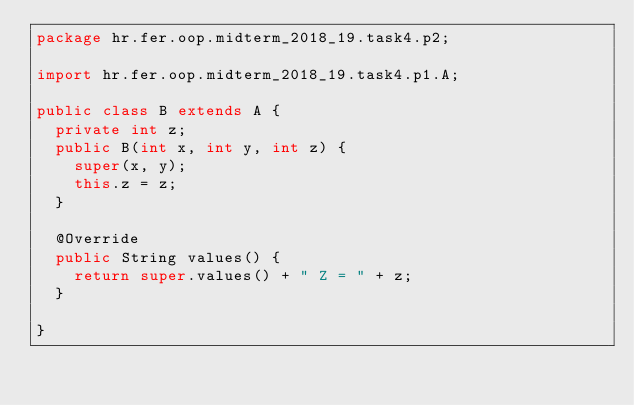Convert code to text. <code><loc_0><loc_0><loc_500><loc_500><_Java_>package hr.fer.oop.midterm_2018_19.task4.p2;

import hr.fer.oop.midterm_2018_19.task4.p1.A;

public class B extends A {
	private int z;
	public B(int x, int y, int z) {
		super(x, y);
		this.z = z;
	}
	
	@Override
	public String values() {		
		return super.values() + " Z = " + z;
	}
		
}
</code> 